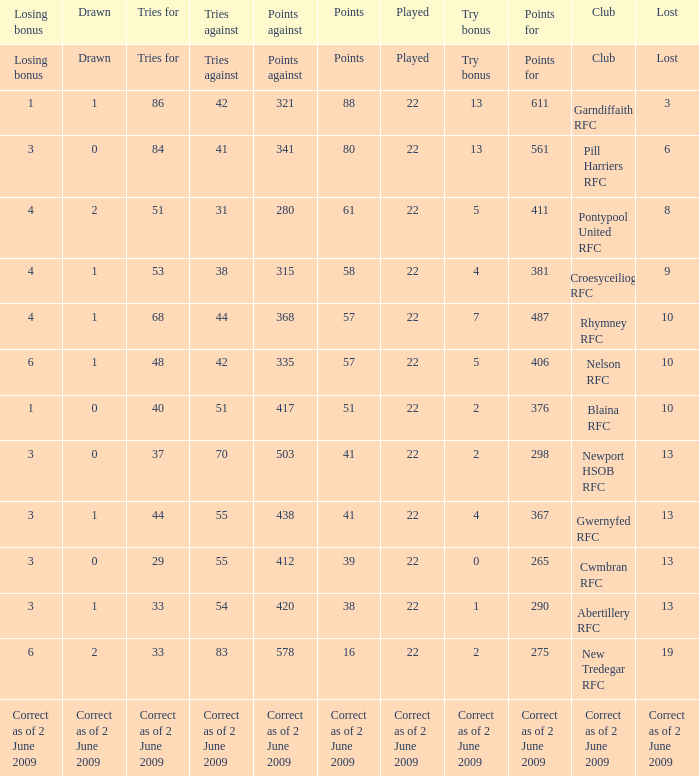How many tries against did the club with 1 drawn and 41 points have? 55.0. 